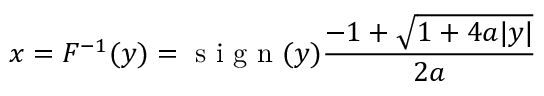Convert formula to latex. <formula><loc_0><loc_0><loc_500><loc_500>x = F ^ { - 1 } ( y ) = s i g n ( y ) \frac { - 1 + \sqrt { 1 + 4 a | y | } } { 2 a }</formula> 